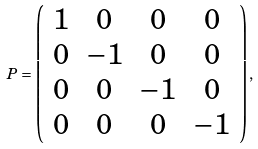<formula> <loc_0><loc_0><loc_500><loc_500>P = \left ( \begin{array} { c c c c } 1 & 0 & 0 & 0 \\ 0 & - 1 & 0 & 0 \\ 0 & 0 & - 1 & 0 \\ 0 & 0 & 0 & - 1 \end{array} \right ) ,</formula> 